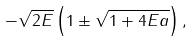Convert formula to latex. <formula><loc_0><loc_0><loc_500><loc_500>- \sqrt { 2 E } \left ( 1 \pm \sqrt { 1 + 4 E a } \right ) ,</formula> 